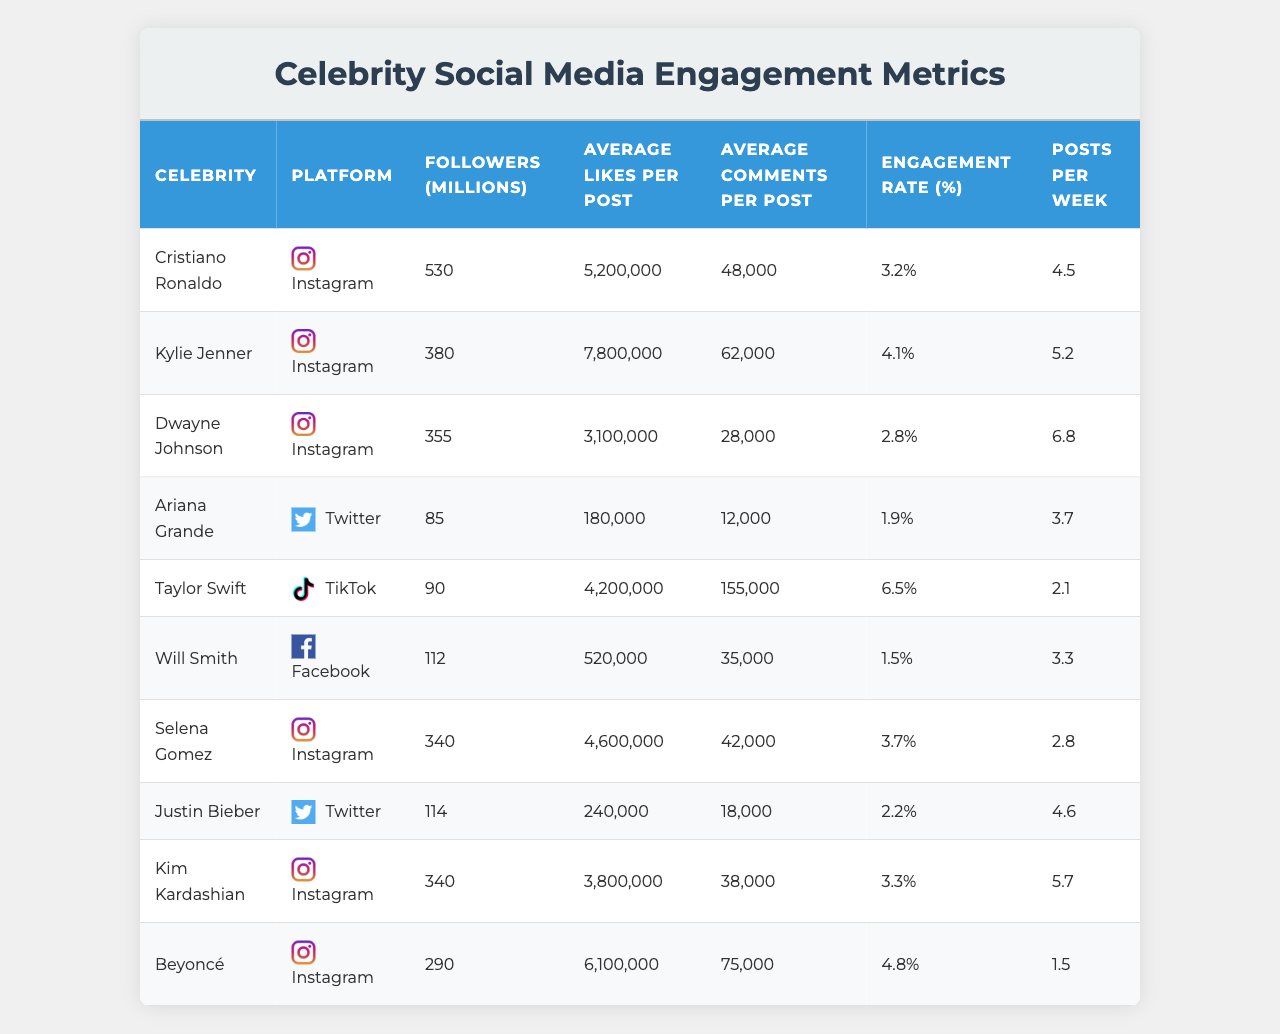What is the engagement rate of Beyoncé on Instagram? The engagement rate of Beyoncé can be found in the table under the "Engagement Rate (%)" column next to her name. It shows that her engagement rate is 4.8%.
Answer: 4.8% Which celebrity has the highest average likes per post? By examining the "Average Likes per Post" column, Kylie Jenner has the highest average likes at 7,800,000.
Answer: Kylie Jenner What is the average number of followers for all celebrities listed? To find the average number of followers, sum the followers for all celebrities (530 + 380 + 355 + 85 + 90 + 112 + 340 + 114 + 340 + 290 = 2,396), and divide by the total number of celebrities (10). The average is 239.6 million followers.
Answer: 239.6 million Is Selena Gomez more engaged than Dwayne Johnson based on engagement rates? Selena Gomez has an engagement rate of 3.7%, while Dwayne Johnson's engagement rate is 2.8%. Therefore, Selena Gomez is more engaged than Dwayne Johnson.
Answer: Yes What is the total number of average comments per post for the celebrities listed? The total average comments per post can be calculated by summing up all the average comments (48,000 + 62,000 + 28,000 + 12,000 + 155,000 + 35,000 + 42,000 + 18,000 + 38,000 + 75,000 = 507,000).
Answer: 507,000 Which social media platform has the most celebrities listed in this table? By examining the "Platform" column, the platform with the most celebrities is Instagram, as six celebrities (Cristiano Ronaldo, Kylie Jenner, Dwayne Johnson, Selena Gomez, Kim Kardashian, Beyoncé) are listed.
Answer: Instagram Who has the most posts per week among the celebrities shown? Checking the "Posts per Week" column, Dwayne Johnson has the most posts at 6.8 posts per week.
Answer: Dwayne Johnson What is the difference in engagement rates between Taylor Swift and Will Smith? Taylor Swift has an engagement rate of 6.5% and Will Smith has an engagement rate of 1.5%. The difference is 6.5% - 1.5% = 5%.
Answer: 5% Which celebrity has the lowest average comments per post? Reviewing the "Average Comments per Post" column shows that Ariana Grande has the lowest average comments at 12,000 per post.
Answer: Ariana Grande What are the average likes per post for celebrities using Twitter? The celebrities using Twitter are Ariana Grande and Justin Bieber, with average likes of 180,000 and 240,000 respectively. Their average is (180,000 + 240,000) / 2 = 210,000 likes per post.
Answer: 210,000 likes per post 